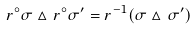<formula> <loc_0><loc_0><loc_500><loc_500>r ^ { \circ } \sigma \vartriangle r ^ { \circ } \sigma ^ { \prime } = r ^ { - 1 } ( \sigma \vartriangle \sigma ^ { \prime } )</formula> 